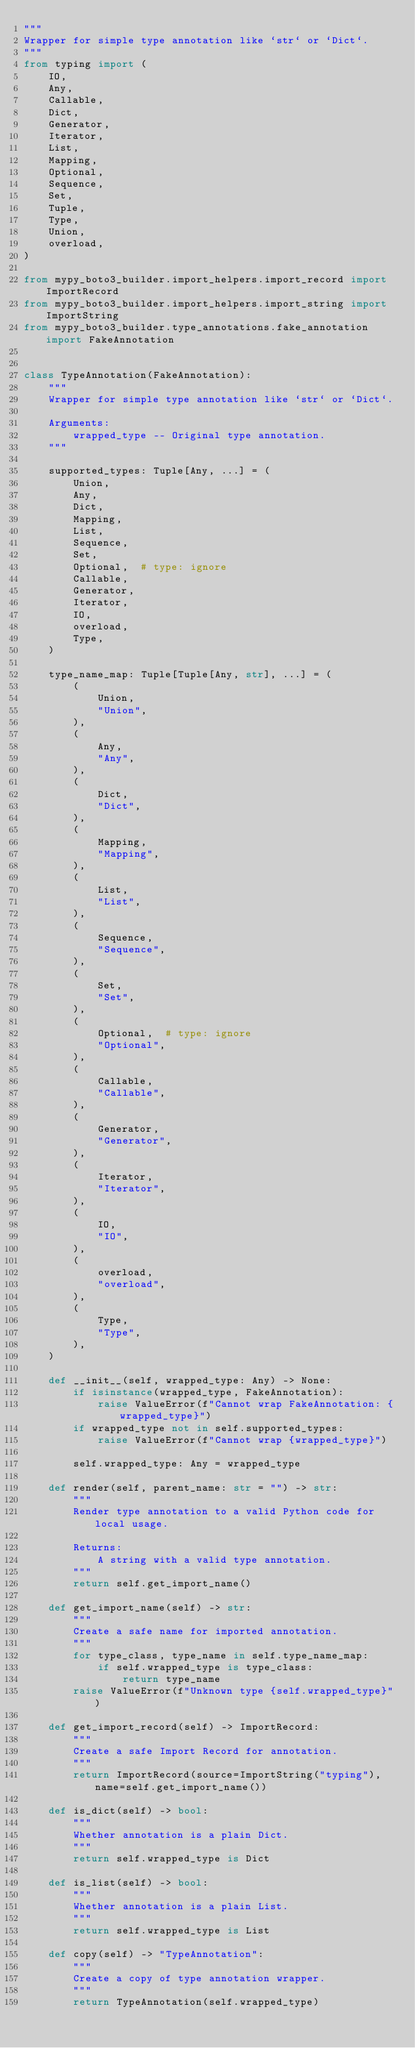Convert code to text. <code><loc_0><loc_0><loc_500><loc_500><_Python_>"""
Wrapper for simple type annotation like `str` or `Dict`.
"""
from typing import (
    IO,
    Any,
    Callable,
    Dict,
    Generator,
    Iterator,
    List,
    Mapping,
    Optional,
    Sequence,
    Set,
    Tuple,
    Type,
    Union,
    overload,
)

from mypy_boto3_builder.import_helpers.import_record import ImportRecord
from mypy_boto3_builder.import_helpers.import_string import ImportString
from mypy_boto3_builder.type_annotations.fake_annotation import FakeAnnotation


class TypeAnnotation(FakeAnnotation):
    """
    Wrapper for simple type annotation like `str` or `Dict`.

    Arguments:
        wrapped_type -- Original type annotation.
    """

    supported_types: Tuple[Any, ...] = (
        Union,
        Any,
        Dict,
        Mapping,
        List,
        Sequence,
        Set,
        Optional,  # type: ignore
        Callable,
        Generator,
        Iterator,
        IO,
        overload,
        Type,
    )

    type_name_map: Tuple[Tuple[Any, str], ...] = (
        (
            Union,
            "Union",
        ),
        (
            Any,
            "Any",
        ),
        (
            Dict,
            "Dict",
        ),
        (
            Mapping,
            "Mapping",
        ),
        (
            List,
            "List",
        ),
        (
            Sequence,
            "Sequence",
        ),
        (
            Set,
            "Set",
        ),
        (
            Optional,  # type: ignore
            "Optional",
        ),
        (
            Callable,
            "Callable",
        ),
        (
            Generator,
            "Generator",
        ),
        (
            Iterator,
            "Iterator",
        ),
        (
            IO,
            "IO",
        ),
        (
            overload,
            "overload",
        ),
        (
            Type,
            "Type",
        ),
    )

    def __init__(self, wrapped_type: Any) -> None:
        if isinstance(wrapped_type, FakeAnnotation):
            raise ValueError(f"Cannot wrap FakeAnnotation: {wrapped_type}")
        if wrapped_type not in self.supported_types:
            raise ValueError(f"Cannot wrap {wrapped_type}")

        self.wrapped_type: Any = wrapped_type

    def render(self, parent_name: str = "") -> str:
        """
        Render type annotation to a valid Python code for local usage.

        Returns:
            A string with a valid type annotation.
        """
        return self.get_import_name()

    def get_import_name(self) -> str:
        """
        Create a safe name for imported annotation.
        """
        for type_class, type_name in self.type_name_map:
            if self.wrapped_type is type_class:
                return type_name
        raise ValueError(f"Unknown type {self.wrapped_type}")

    def get_import_record(self) -> ImportRecord:
        """
        Create a safe Import Record for annotation.
        """
        return ImportRecord(source=ImportString("typing"), name=self.get_import_name())

    def is_dict(self) -> bool:
        """
        Whether annotation is a plain Dict.
        """
        return self.wrapped_type is Dict

    def is_list(self) -> bool:
        """
        Whether annotation is a plain List.
        """
        return self.wrapped_type is List

    def copy(self) -> "TypeAnnotation":
        """
        Create a copy of type annotation wrapper.
        """
        return TypeAnnotation(self.wrapped_type)
</code> 